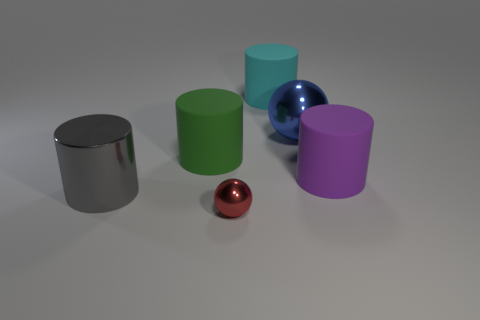Subtract all matte cylinders. How many cylinders are left? 1 Subtract 1 cylinders. How many cylinders are left? 3 Add 2 small rubber cylinders. How many objects exist? 8 Subtract all red spheres. How many spheres are left? 1 Subtract all spheres. How many objects are left? 4 Subtract all green cylinders. How many red balls are left? 1 Subtract all blue metallic balls. Subtract all tiny green matte spheres. How many objects are left? 5 Add 4 blue metal objects. How many blue metal objects are left? 5 Add 6 tiny metallic spheres. How many tiny metallic spheres exist? 7 Subtract 0 purple cubes. How many objects are left? 6 